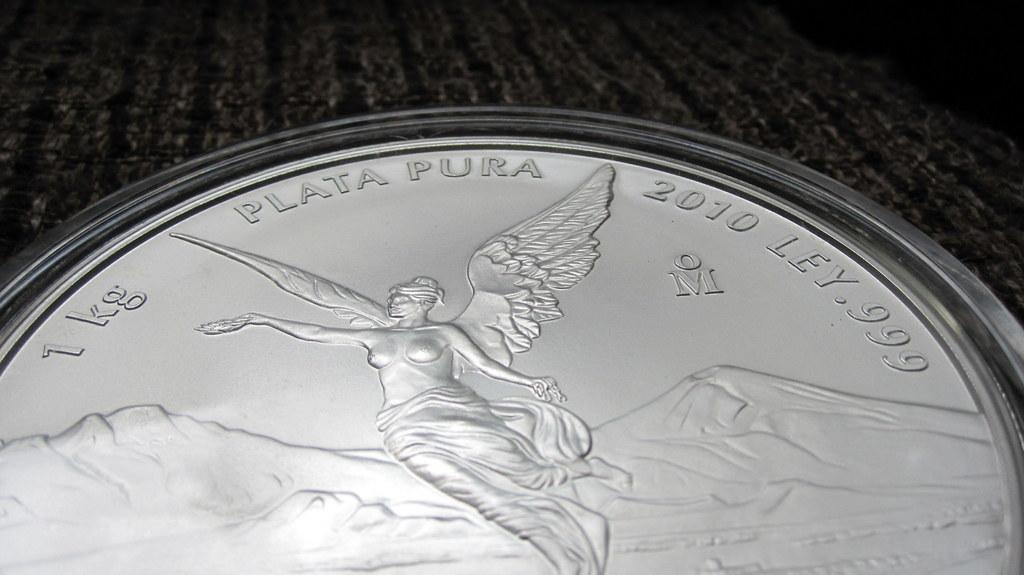What is the main subject of the image? There is an object in the image. Can you describe the appearance of the object? The object is silver in color. Are there any words or text on the object? Yes, there are words written on the object. Is there any image or design on the object? Yes, there is a picture on the object. How many strands of hair can be seen on the object in the image? There is no hair present on the object in the image. What type of fish is swimming in the picture on the object? There is no fish or any aquatic life depicted in the image, as the object has a picture but not of a fish. 